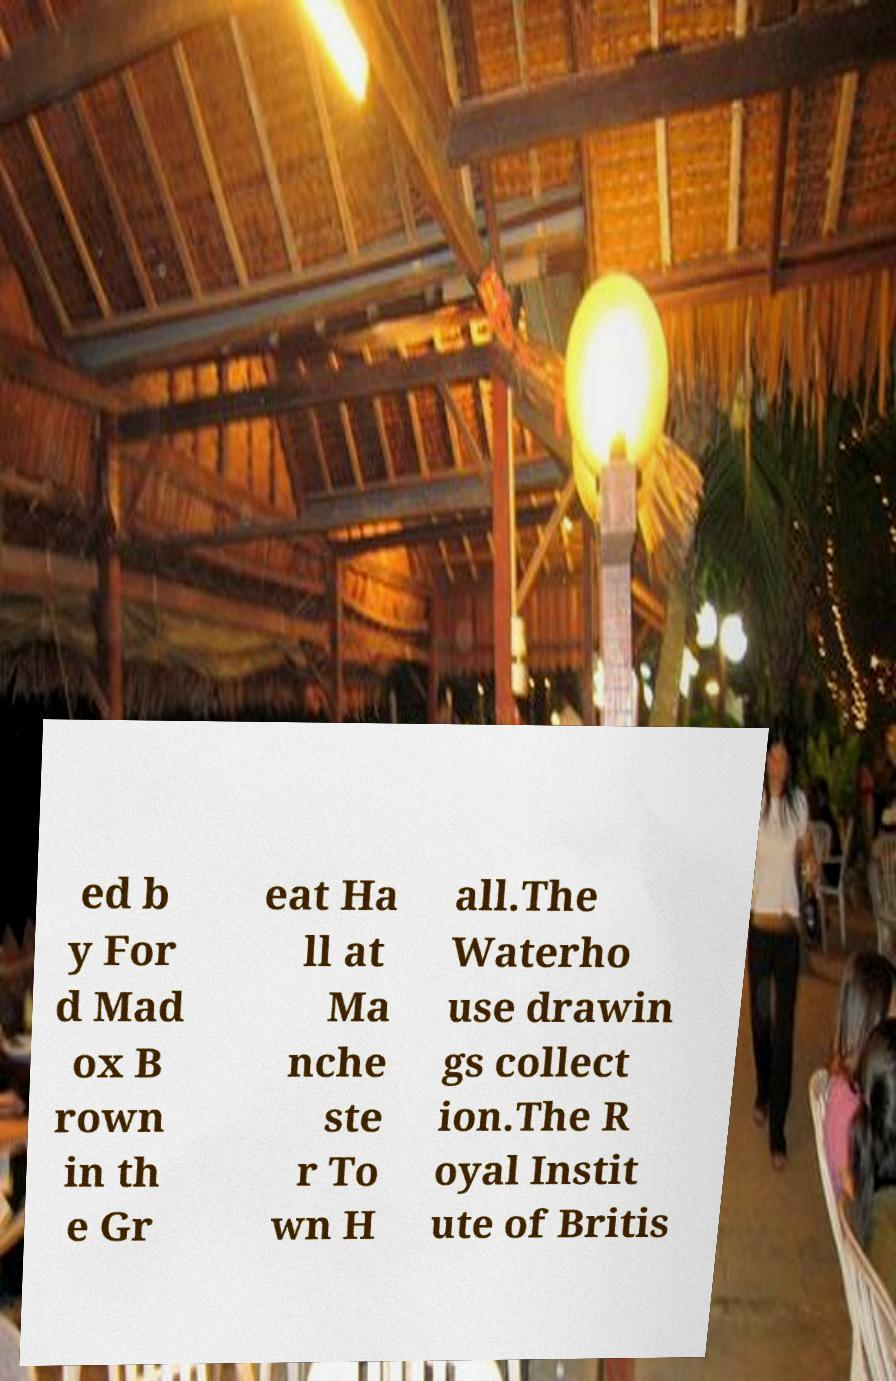Please identify and transcribe the text found in this image. ed b y For d Mad ox B rown in th e Gr eat Ha ll at Ma nche ste r To wn H all.The Waterho use drawin gs collect ion.The R oyal Instit ute of Britis 